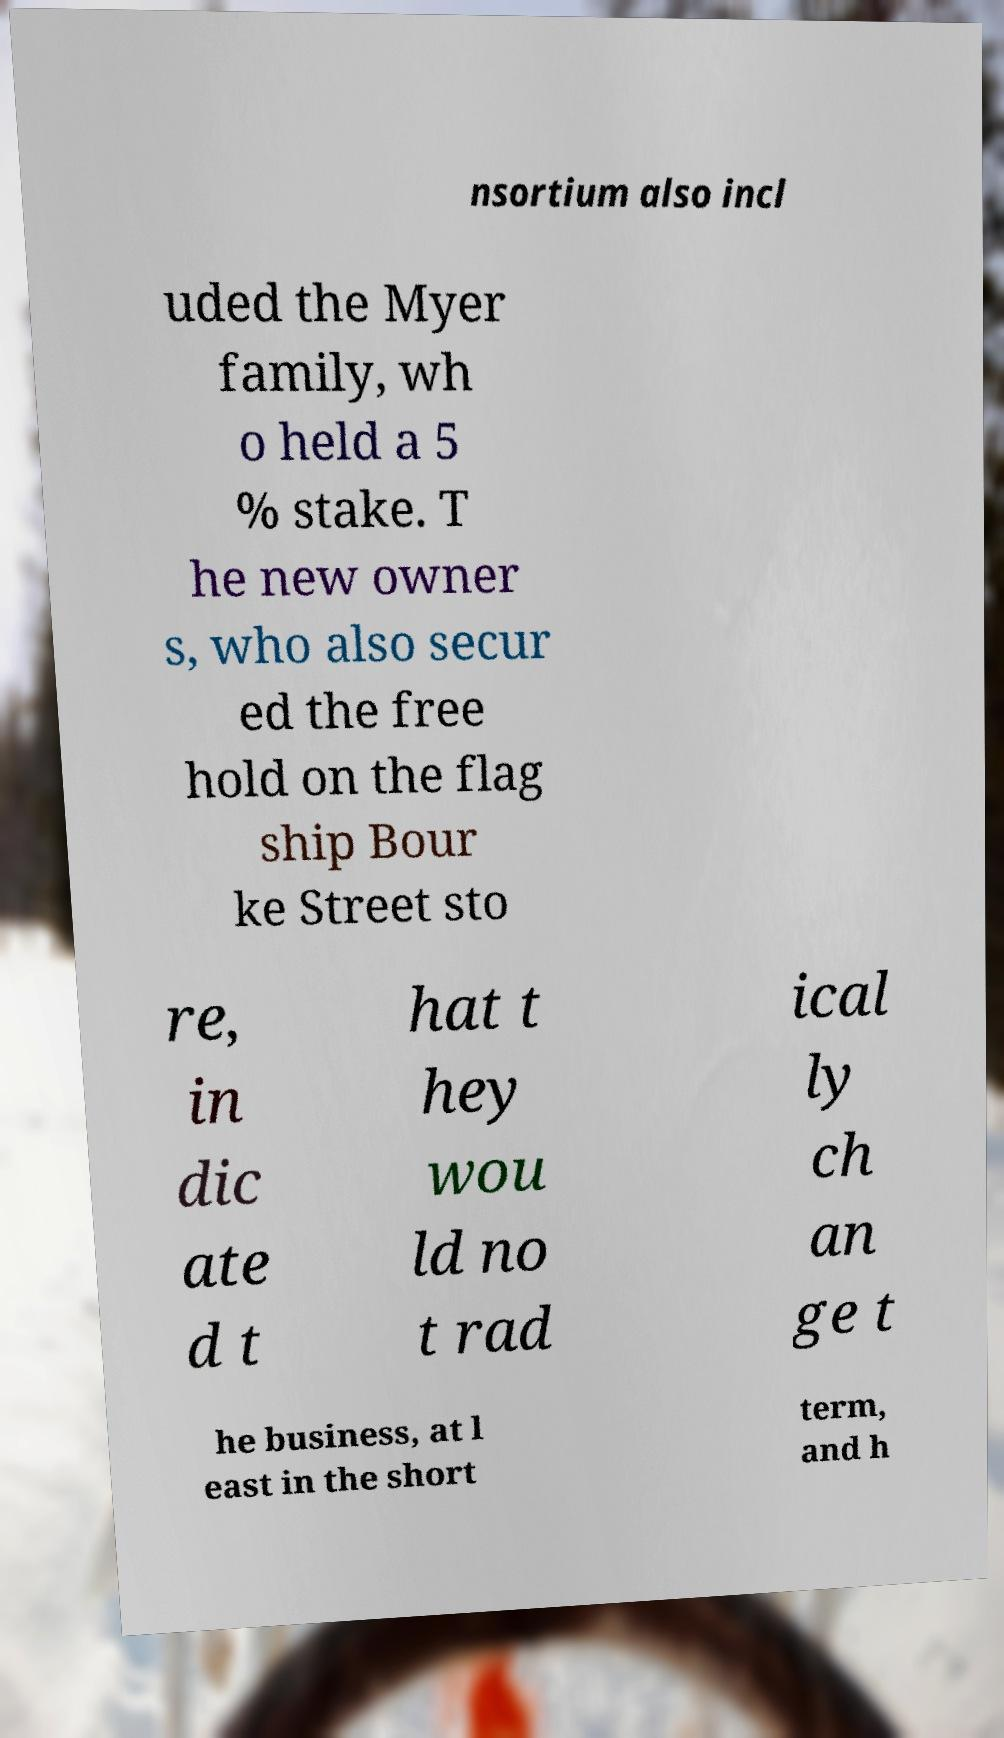Could you extract and type out the text from this image? nsortium also incl uded the Myer family, wh o held a 5 % stake. T he new owner s, who also secur ed the free hold on the flag ship Bour ke Street sto re, in dic ate d t hat t hey wou ld no t rad ical ly ch an ge t he business, at l east in the short term, and h 